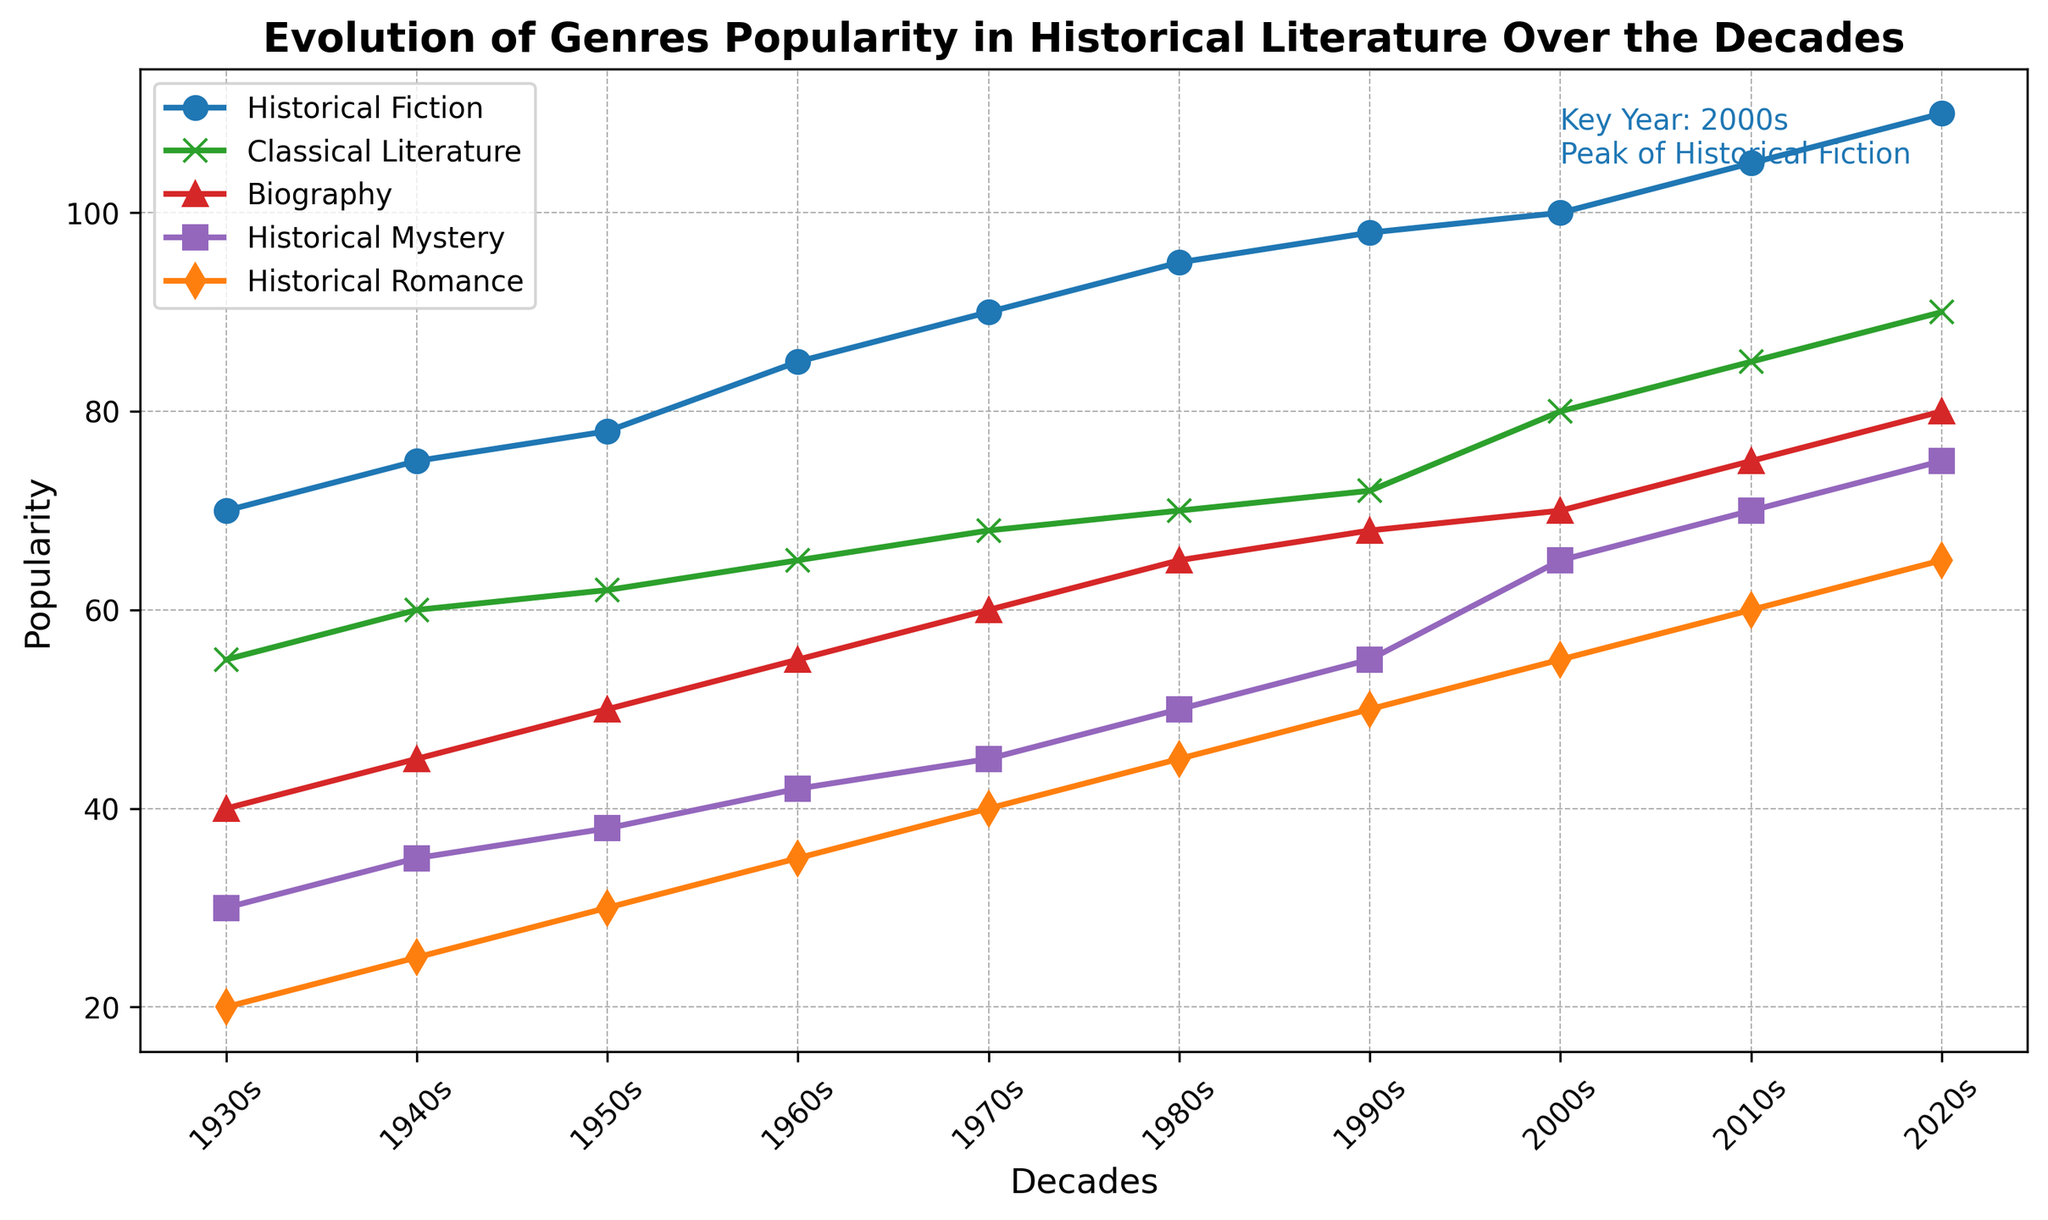What's the most popular genre in the 2020s? Look at the 2020s data points and find the genre with the highest value. Historical Fiction reaches the highest value at 110.
Answer: Historical Fiction Which genre has the least growth from the 1930s to the 2020s? Calculate the difference for each genre from the 1930s to the 2020s. Classical Literature has grown from 55 to 90, which is the smallest increase (35).
Answer: Classical Literature Compare the popularity of Historical Romance and Historical Mystery in the 1980s. Which one is more popular? Look at the data points for the 1980s. Historical Romance has a value of 45, while Historical Mystery has a value of 50. Historical Mystery is more popular.
Answer: Historical Mystery How did the popularity of Biography change from the 1940s to the 2000s? Find the values of Biography in the 1940s (45) and the 2000s (70). Subtract the 1940s value from the 2000s value (70 - 45 = 25).
Answer: Increased by 25 What decade did Historical Fiction reach its peak according to the text annotation? Read the text annotation on the graph, which mentions the peak of Historical Fiction in the 2000s.
Answer: 2000s What is the difference in popularity between Historical Fiction and Classical Literature in the 1960s? Find the values of Historical Fiction (85) and Classical Literature (65) in the 1960s and subtract the latter from the former (85 - 65 = 20).
Answer: 20 Which genre shows the most consistent increase in popularity over the decades? Observe the line trends for each genre. Historical Fiction shows the most consistent increase without any dips or flat periods.
Answer: Historical Fiction How does the popularity of Historical Fiction in the 2010s compare to the 1930s? Look at the values in the 2010s (105) and 1930s (70). Calculate the difference (105 - 70 = 35).
Answer: Increased by 35 Which genre was equally popular in the 2000s and 2010s? Look at the values in the 2000s and 2010s. Only Classical Literature (80 in 2000s and 85 in 2010s) show a linear close increase but not equal, none of them are equal.
Answer: None What's the overall trend of Classical Literature from 1930s to 2020s? Observe the values of Classical Literature over the decades (55 to 90), which shows a steady increase.
Answer: Steady increase 